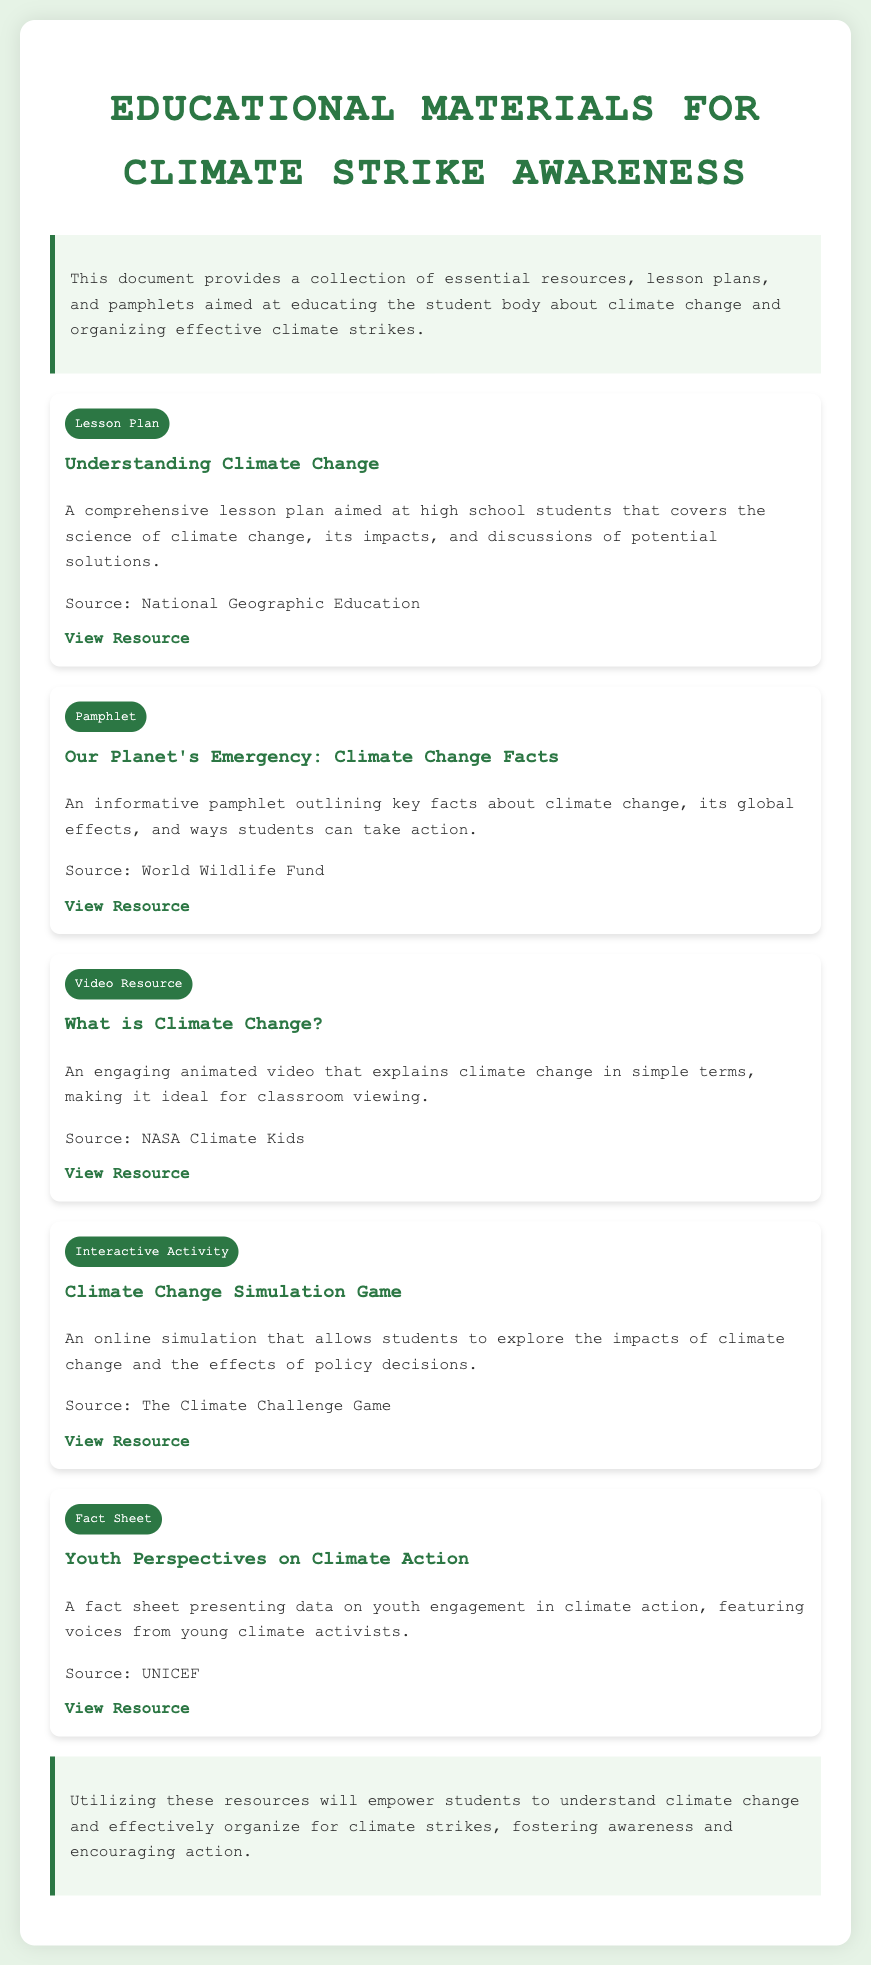What is the title of the document? The title is prominently displayed at the top of the document, indicating the main subject matter.
Answer: Educational Materials for Climate Strike Awareness Who is the source of the "Understanding Climate Change" lesson plan? The source is mentioned in the description of the lesson plan, providing credit for the resource.
Answer: National Geographic Education What type of resource is "Our Planet's Emergency: Climate Change Facts"? Each resource is labeled with a type to categorize it, indicating its format or purpose.
Answer: Pamphlet What is a key benefit of the resources listed in the document? The introduction states the main purpose of the resources, highlighting their utility in education and activism.
Answer: Empower students How many different types of resources are featured in the document? By counting the types of resources listed, you can determine the variety provided.
Answer: Five What is the focus of the "Youth Perspectives on Climate Action" fact sheet? The description details the subject matter of this fact sheet, emphasizing its relevance to a specific group.
Answer: Youth engagement 